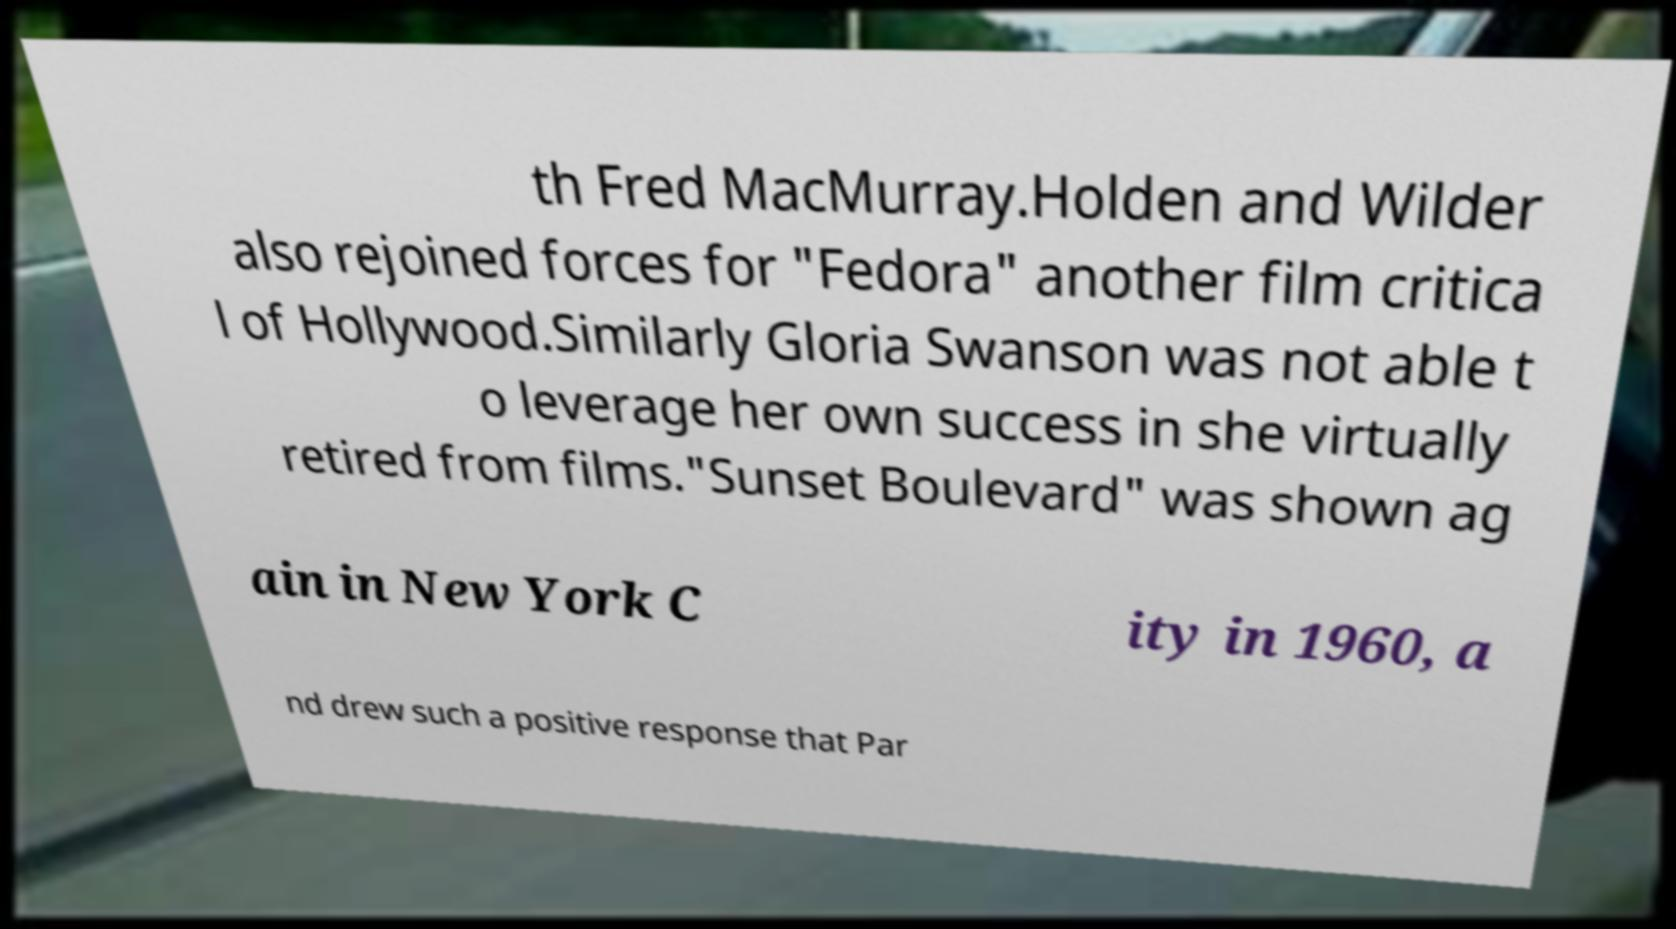Could you extract and type out the text from this image? th Fred MacMurray.Holden and Wilder also rejoined forces for "Fedora" another film critica l of Hollywood.Similarly Gloria Swanson was not able t o leverage her own success in she virtually retired from films."Sunset Boulevard" was shown ag ain in New York C ity in 1960, a nd drew such a positive response that Par 